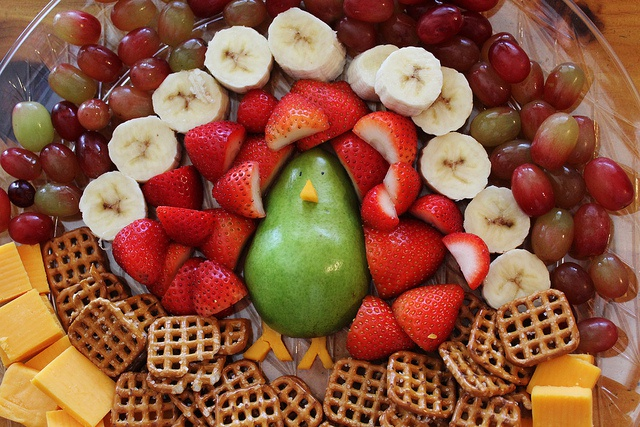Describe the objects in this image and their specific colors. I can see banana in gray, tan, and lightgray tones, banana in gray and tan tones, and banana in gray, lightgray, beige, tan, and salmon tones in this image. 